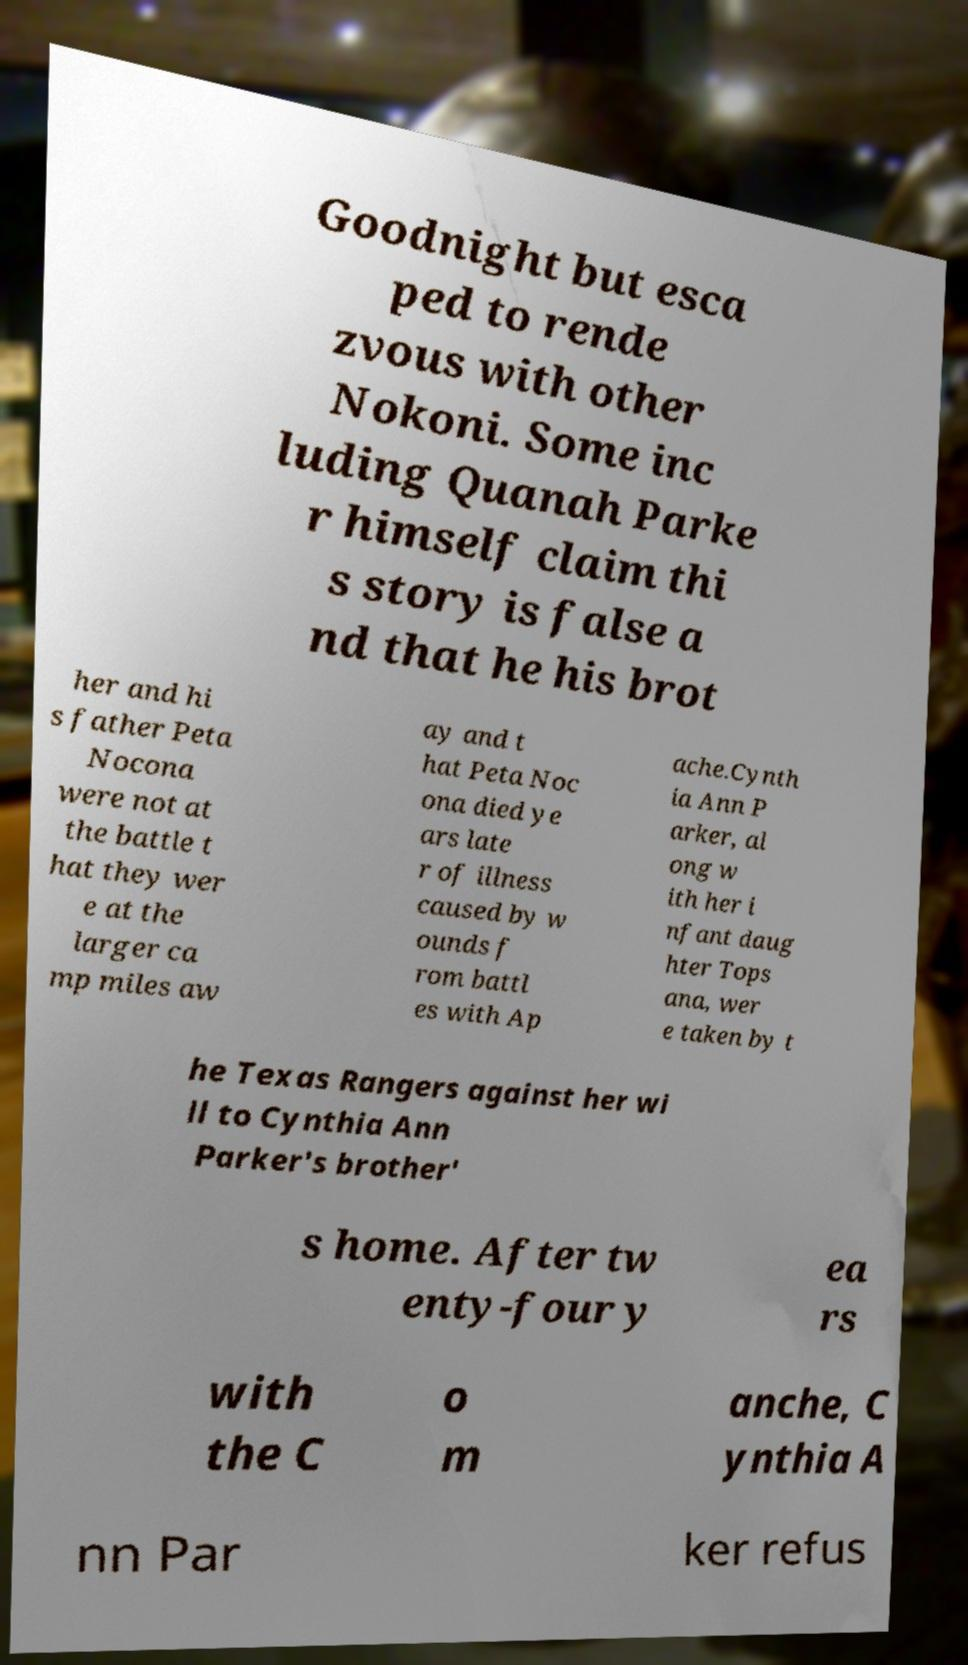Could you assist in decoding the text presented in this image and type it out clearly? Goodnight but esca ped to rende zvous with other Nokoni. Some inc luding Quanah Parke r himself claim thi s story is false a nd that he his brot her and hi s father Peta Nocona were not at the battle t hat they wer e at the larger ca mp miles aw ay and t hat Peta Noc ona died ye ars late r of illness caused by w ounds f rom battl es with Ap ache.Cynth ia Ann P arker, al ong w ith her i nfant daug hter Tops ana, wer e taken by t he Texas Rangers against her wi ll to Cynthia Ann Parker's brother' s home. After tw enty-four y ea rs with the C o m anche, C ynthia A nn Par ker refus 